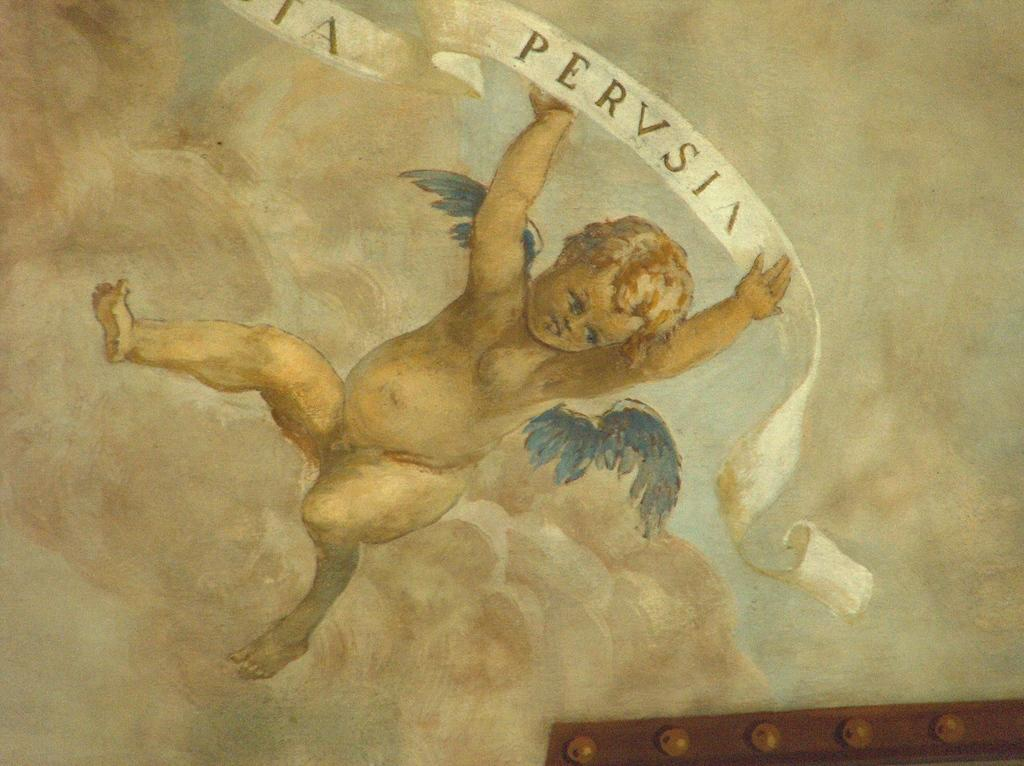What type of artwork is shown in the image? The image is a painting. What is the main subject of the painting? The painting depicts a kid. What distinguishing feature does the kid have? The kid has wings. What is the kid holding in the painting? The kid is holding something. Can you describe the object the kid is holding? There is writing on the object the kid is holding. Where is the boat located in the painting? There is no boat present in the painting. What type of railway can be seen in the painting? There is no railway present in the painting. 